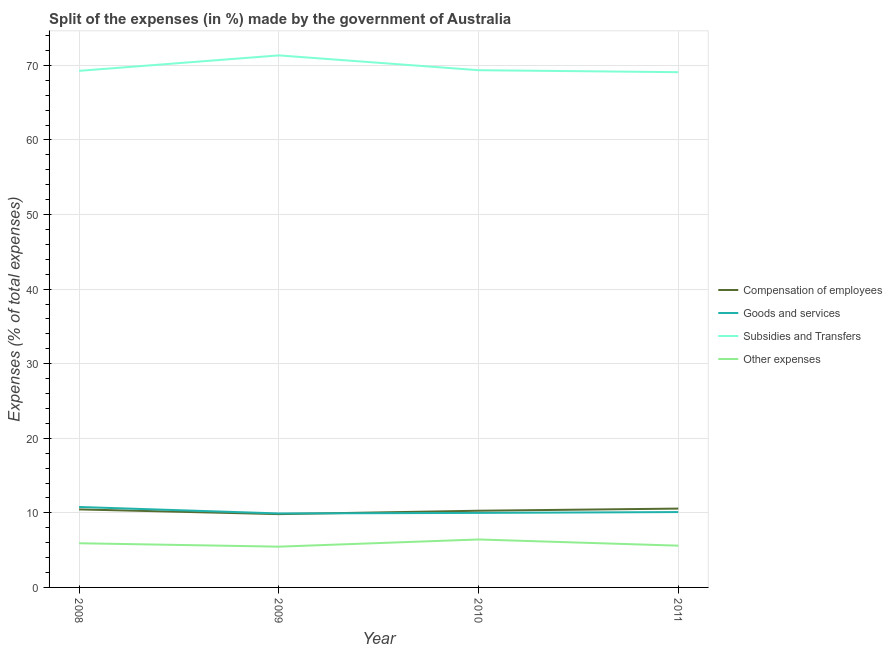How many different coloured lines are there?
Offer a very short reply. 4. Does the line corresponding to percentage of amount spent on other expenses intersect with the line corresponding to percentage of amount spent on goods and services?
Your answer should be compact. No. Is the number of lines equal to the number of legend labels?
Provide a short and direct response. Yes. What is the percentage of amount spent on compensation of employees in 2011?
Your answer should be compact. 10.57. Across all years, what is the maximum percentage of amount spent on other expenses?
Your answer should be very brief. 6.43. Across all years, what is the minimum percentage of amount spent on compensation of employees?
Your answer should be very brief. 9.83. In which year was the percentage of amount spent on other expenses minimum?
Provide a succinct answer. 2009. What is the total percentage of amount spent on compensation of employees in the graph?
Ensure brevity in your answer.  41.14. What is the difference between the percentage of amount spent on goods and services in 2008 and that in 2009?
Your answer should be compact. 0.87. What is the difference between the percentage of amount spent on other expenses in 2011 and the percentage of amount spent on goods and services in 2008?
Offer a terse response. -5.19. What is the average percentage of amount spent on subsidies per year?
Keep it short and to the point. 69.76. In the year 2011, what is the difference between the percentage of amount spent on subsidies and percentage of amount spent on goods and services?
Your answer should be very brief. 58.98. In how many years, is the percentage of amount spent on goods and services greater than 22 %?
Your answer should be very brief. 0. What is the ratio of the percentage of amount spent on compensation of employees in 2009 to that in 2011?
Your answer should be compact. 0.93. Is the difference between the percentage of amount spent on compensation of employees in 2008 and 2011 greater than the difference between the percentage of amount spent on goods and services in 2008 and 2011?
Your answer should be compact. No. What is the difference between the highest and the second highest percentage of amount spent on compensation of employees?
Provide a short and direct response. 0.11. What is the difference between the highest and the lowest percentage of amount spent on goods and services?
Give a very brief answer. 0.87. In how many years, is the percentage of amount spent on other expenses greater than the average percentage of amount spent on other expenses taken over all years?
Keep it short and to the point. 2. Is it the case that in every year, the sum of the percentage of amount spent on compensation of employees and percentage of amount spent on subsidies is greater than the sum of percentage of amount spent on goods and services and percentage of amount spent on other expenses?
Your answer should be very brief. Yes. Is it the case that in every year, the sum of the percentage of amount spent on compensation of employees and percentage of amount spent on goods and services is greater than the percentage of amount spent on subsidies?
Provide a short and direct response. No. Does the percentage of amount spent on compensation of employees monotonically increase over the years?
Ensure brevity in your answer.  No. Is the percentage of amount spent on compensation of employees strictly less than the percentage of amount spent on other expenses over the years?
Keep it short and to the point. No. What is the difference between two consecutive major ticks on the Y-axis?
Your answer should be compact. 10. Does the graph contain any zero values?
Provide a short and direct response. No. Does the graph contain grids?
Provide a short and direct response. Yes. How many legend labels are there?
Make the answer very short. 4. What is the title of the graph?
Your answer should be compact. Split of the expenses (in %) made by the government of Australia. Does "Sweden" appear as one of the legend labels in the graph?
Your response must be concise. No. What is the label or title of the Y-axis?
Offer a terse response. Expenses (% of total expenses). What is the Expenses (% of total expenses) of Compensation of employees in 2008?
Provide a short and direct response. 10.46. What is the Expenses (% of total expenses) in Goods and services in 2008?
Offer a very short reply. 10.79. What is the Expenses (% of total expenses) in Subsidies and Transfers in 2008?
Your response must be concise. 69.27. What is the Expenses (% of total expenses) in Other expenses in 2008?
Make the answer very short. 5.92. What is the Expenses (% of total expenses) of Compensation of employees in 2009?
Offer a terse response. 9.83. What is the Expenses (% of total expenses) of Goods and services in 2009?
Offer a terse response. 9.92. What is the Expenses (% of total expenses) in Subsidies and Transfers in 2009?
Ensure brevity in your answer.  71.34. What is the Expenses (% of total expenses) in Other expenses in 2009?
Your answer should be very brief. 5.47. What is the Expenses (% of total expenses) in Compensation of employees in 2010?
Your response must be concise. 10.28. What is the Expenses (% of total expenses) in Goods and services in 2010?
Offer a very short reply. 9.99. What is the Expenses (% of total expenses) in Subsidies and Transfers in 2010?
Offer a terse response. 69.35. What is the Expenses (% of total expenses) of Other expenses in 2010?
Provide a succinct answer. 6.43. What is the Expenses (% of total expenses) in Compensation of employees in 2011?
Offer a terse response. 10.57. What is the Expenses (% of total expenses) in Goods and services in 2011?
Your answer should be very brief. 10.11. What is the Expenses (% of total expenses) of Subsidies and Transfers in 2011?
Your response must be concise. 69.09. What is the Expenses (% of total expenses) of Other expenses in 2011?
Your answer should be compact. 5.6. Across all years, what is the maximum Expenses (% of total expenses) of Compensation of employees?
Offer a terse response. 10.57. Across all years, what is the maximum Expenses (% of total expenses) of Goods and services?
Give a very brief answer. 10.79. Across all years, what is the maximum Expenses (% of total expenses) of Subsidies and Transfers?
Offer a very short reply. 71.34. Across all years, what is the maximum Expenses (% of total expenses) of Other expenses?
Keep it short and to the point. 6.43. Across all years, what is the minimum Expenses (% of total expenses) of Compensation of employees?
Offer a terse response. 9.83. Across all years, what is the minimum Expenses (% of total expenses) of Goods and services?
Your answer should be compact. 9.92. Across all years, what is the minimum Expenses (% of total expenses) of Subsidies and Transfers?
Provide a succinct answer. 69.09. Across all years, what is the minimum Expenses (% of total expenses) in Other expenses?
Offer a terse response. 5.47. What is the total Expenses (% of total expenses) of Compensation of employees in the graph?
Offer a very short reply. 41.14. What is the total Expenses (% of total expenses) in Goods and services in the graph?
Your answer should be very brief. 40.8. What is the total Expenses (% of total expenses) of Subsidies and Transfers in the graph?
Ensure brevity in your answer.  279.05. What is the total Expenses (% of total expenses) in Other expenses in the graph?
Your answer should be compact. 23.42. What is the difference between the Expenses (% of total expenses) of Compensation of employees in 2008 and that in 2009?
Provide a succinct answer. 0.63. What is the difference between the Expenses (% of total expenses) of Goods and services in 2008 and that in 2009?
Offer a terse response. 0.87. What is the difference between the Expenses (% of total expenses) of Subsidies and Transfers in 2008 and that in 2009?
Offer a terse response. -2.07. What is the difference between the Expenses (% of total expenses) of Other expenses in 2008 and that in 2009?
Your answer should be very brief. 0.46. What is the difference between the Expenses (% of total expenses) in Compensation of employees in 2008 and that in 2010?
Ensure brevity in your answer.  0.18. What is the difference between the Expenses (% of total expenses) of Goods and services in 2008 and that in 2010?
Keep it short and to the point. 0.79. What is the difference between the Expenses (% of total expenses) of Subsidies and Transfers in 2008 and that in 2010?
Offer a terse response. -0.09. What is the difference between the Expenses (% of total expenses) of Other expenses in 2008 and that in 2010?
Offer a very short reply. -0.51. What is the difference between the Expenses (% of total expenses) of Compensation of employees in 2008 and that in 2011?
Provide a succinct answer. -0.11. What is the difference between the Expenses (% of total expenses) of Goods and services in 2008 and that in 2011?
Ensure brevity in your answer.  0.68. What is the difference between the Expenses (% of total expenses) in Subsidies and Transfers in 2008 and that in 2011?
Give a very brief answer. 0.18. What is the difference between the Expenses (% of total expenses) in Other expenses in 2008 and that in 2011?
Offer a terse response. 0.33. What is the difference between the Expenses (% of total expenses) in Compensation of employees in 2009 and that in 2010?
Your answer should be very brief. -0.45. What is the difference between the Expenses (% of total expenses) in Goods and services in 2009 and that in 2010?
Offer a terse response. -0.07. What is the difference between the Expenses (% of total expenses) in Subsidies and Transfers in 2009 and that in 2010?
Your answer should be very brief. 1.99. What is the difference between the Expenses (% of total expenses) in Other expenses in 2009 and that in 2010?
Ensure brevity in your answer.  -0.96. What is the difference between the Expenses (% of total expenses) of Compensation of employees in 2009 and that in 2011?
Your answer should be very brief. -0.74. What is the difference between the Expenses (% of total expenses) of Goods and services in 2009 and that in 2011?
Provide a short and direct response. -0.19. What is the difference between the Expenses (% of total expenses) of Subsidies and Transfers in 2009 and that in 2011?
Ensure brevity in your answer.  2.25. What is the difference between the Expenses (% of total expenses) of Other expenses in 2009 and that in 2011?
Ensure brevity in your answer.  -0.13. What is the difference between the Expenses (% of total expenses) of Compensation of employees in 2010 and that in 2011?
Provide a short and direct response. -0.29. What is the difference between the Expenses (% of total expenses) in Goods and services in 2010 and that in 2011?
Your response must be concise. -0.11. What is the difference between the Expenses (% of total expenses) of Subsidies and Transfers in 2010 and that in 2011?
Provide a succinct answer. 0.27. What is the difference between the Expenses (% of total expenses) of Other expenses in 2010 and that in 2011?
Give a very brief answer. 0.83. What is the difference between the Expenses (% of total expenses) of Compensation of employees in 2008 and the Expenses (% of total expenses) of Goods and services in 2009?
Your answer should be compact. 0.54. What is the difference between the Expenses (% of total expenses) of Compensation of employees in 2008 and the Expenses (% of total expenses) of Subsidies and Transfers in 2009?
Your answer should be very brief. -60.88. What is the difference between the Expenses (% of total expenses) in Compensation of employees in 2008 and the Expenses (% of total expenses) in Other expenses in 2009?
Provide a succinct answer. 4.99. What is the difference between the Expenses (% of total expenses) in Goods and services in 2008 and the Expenses (% of total expenses) in Subsidies and Transfers in 2009?
Ensure brevity in your answer.  -60.55. What is the difference between the Expenses (% of total expenses) in Goods and services in 2008 and the Expenses (% of total expenses) in Other expenses in 2009?
Offer a very short reply. 5.32. What is the difference between the Expenses (% of total expenses) of Subsidies and Transfers in 2008 and the Expenses (% of total expenses) of Other expenses in 2009?
Your response must be concise. 63.8. What is the difference between the Expenses (% of total expenses) in Compensation of employees in 2008 and the Expenses (% of total expenses) in Goods and services in 2010?
Provide a short and direct response. 0.47. What is the difference between the Expenses (% of total expenses) in Compensation of employees in 2008 and the Expenses (% of total expenses) in Subsidies and Transfers in 2010?
Your answer should be very brief. -58.89. What is the difference between the Expenses (% of total expenses) in Compensation of employees in 2008 and the Expenses (% of total expenses) in Other expenses in 2010?
Ensure brevity in your answer.  4.03. What is the difference between the Expenses (% of total expenses) in Goods and services in 2008 and the Expenses (% of total expenses) in Subsidies and Transfers in 2010?
Provide a short and direct response. -58.57. What is the difference between the Expenses (% of total expenses) in Goods and services in 2008 and the Expenses (% of total expenses) in Other expenses in 2010?
Keep it short and to the point. 4.36. What is the difference between the Expenses (% of total expenses) in Subsidies and Transfers in 2008 and the Expenses (% of total expenses) in Other expenses in 2010?
Give a very brief answer. 62.84. What is the difference between the Expenses (% of total expenses) in Compensation of employees in 2008 and the Expenses (% of total expenses) in Goods and services in 2011?
Provide a short and direct response. 0.36. What is the difference between the Expenses (% of total expenses) in Compensation of employees in 2008 and the Expenses (% of total expenses) in Subsidies and Transfers in 2011?
Give a very brief answer. -58.63. What is the difference between the Expenses (% of total expenses) in Compensation of employees in 2008 and the Expenses (% of total expenses) in Other expenses in 2011?
Ensure brevity in your answer.  4.86. What is the difference between the Expenses (% of total expenses) of Goods and services in 2008 and the Expenses (% of total expenses) of Subsidies and Transfers in 2011?
Keep it short and to the point. -58.3. What is the difference between the Expenses (% of total expenses) in Goods and services in 2008 and the Expenses (% of total expenses) in Other expenses in 2011?
Your answer should be compact. 5.19. What is the difference between the Expenses (% of total expenses) in Subsidies and Transfers in 2008 and the Expenses (% of total expenses) in Other expenses in 2011?
Your answer should be very brief. 63.67. What is the difference between the Expenses (% of total expenses) of Compensation of employees in 2009 and the Expenses (% of total expenses) of Goods and services in 2010?
Provide a succinct answer. -0.17. What is the difference between the Expenses (% of total expenses) in Compensation of employees in 2009 and the Expenses (% of total expenses) in Subsidies and Transfers in 2010?
Give a very brief answer. -59.53. What is the difference between the Expenses (% of total expenses) of Compensation of employees in 2009 and the Expenses (% of total expenses) of Other expenses in 2010?
Make the answer very short. 3.4. What is the difference between the Expenses (% of total expenses) in Goods and services in 2009 and the Expenses (% of total expenses) in Subsidies and Transfers in 2010?
Your response must be concise. -59.43. What is the difference between the Expenses (% of total expenses) of Goods and services in 2009 and the Expenses (% of total expenses) of Other expenses in 2010?
Provide a succinct answer. 3.49. What is the difference between the Expenses (% of total expenses) in Subsidies and Transfers in 2009 and the Expenses (% of total expenses) in Other expenses in 2010?
Ensure brevity in your answer.  64.91. What is the difference between the Expenses (% of total expenses) in Compensation of employees in 2009 and the Expenses (% of total expenses) in Goods and services in 2011?
Your answer should be very brief. -0.28. What is the difference between the Expenses (% of total expenses) in Compensation of employees in 2009 and the Expenses (% of total expenses) in Subsidies and Transfers in 2011?
Your answer should be very brief. -59.26. What is the difference between the Expenses (% of total expenses) of Compensation of employees in 2009 and the Expenses (% of total expenses) of Other expenses in 2011?
Your answer should be compact. 4.23. What is the difference between the Expenses (% of total expenses) of Goods and services in 2009 and the Expenses (% of total expenses) of Subsidies and Transfers in 2011?
Your response must be concise. -59.17. What is the difference between the Expenses (% of total expenses) of Goods and services in 2009 and the Expenses (% of total expenses) of Other expenses in 2011?
Ensure brevity in your answer.  4.32. What is the difference between the Expenses (% of total expenses) in Subsidies and Transfers in 2009 and the Expenses (% of total expenses) in Other expenses in 2011?
Provide a short and direct response. 65.74. What is the difference between the Expenses (% of total expenses) in Compensation of employees in 2010 and the Expenses (% of total expenses) in Goods and services in 2011?
Offer a terse response. 0.18. What is the difference between the Expenses (% of total expenses) of Compensation of employees in 2010 and the Expenses (% of total expenses) of Subsidies and Transfers in 2011?
Keep it short and to the point. -58.81. What is the difference between the Expenses (% of total expenses) of Compensation of employees in 2010 and the Expenses (% of total expenses) of Other expenses in 2011?
Offer a very short reply. 4.68. What is the difference between the Expenses (% of total expenses) of Goods and services in 2010 and the Expenses (% of total expenses) of Subsidies and Transfers in 2011?
Ensure brevity in your answer.  -59.1. What is the difference between the Expenses (% of total expenses) in Goods and services in 2010 and the Expenses (% of total expenses) in Other expenses in 2011?
Give a very brief answer. 4.39. What is the difference between the Expenses (% of total expenses) in Subsidies and Transfers in 2010 and the Expenses (% of total expenses) in Other expenses in 2011?
Keep it short and to the point. 63.76. What is the average Expenses (% of total expenses) of Compensation of employees per year?
Your answer should be very brief. 10.29. What is the average Expenses (% of total expenses) in Goods and services per year?
Provide a short and direct response. 10.2. What is the average Expenses (% of total expenses) in Subsidies and Transfers per year?
Make the answer very short. 69.76. What is the average Expenses (% of total expenses) of Other expenses per year?
Ensure brevity in your answer.  5.85. In the year 2008, what is the difference between the Expenses (% of total expenses) of Compensation of employees and Expenses (% of total expenses) of Goods and services?
Provide a succinct answer. -0.33. In the year 2008, what is the difference between the Expenses (% of total expenses) of Compensation of employees and Expenses (% of total expenses) of Subsidies and Transfers?
Provide a short and direct response. -58.81. In the year 2008, what is the difference between the Expenses (% of total expenses) in Compensation of employees and Expenses (% of total expenses) in Other expenses?
Give a very brief answer. 4.54. In the year 2008, what is the difference between the Expenses (% of total expenses) in Goods and services and Expenses (% of total expenses) in Subsidies and Transfers?
Offer a very short reply. -58.48. In the year 2008, what is the difference between the Expenses (% of total expenses) of Goods and services and Expenses (% of total expenses) of Other expenses?
Your response must be concise. 4.86. In the year 2008, what is the difference between the Expenses (% of total expenses) in Subsidies and Transfers and Expenses (% of total expenses) in Other expenses?
Offer a terse response. 63.34. In the year 2009, what is the difference between the Expenses (% of total expenses) in Compensation of employees and Expenses (% of total expenses) in Goods and services?
Give a very brief answer. -0.09. In the year 2009, what is the difference between the Expenses (% of total expenses) of Compensation of employees and Expenses (% of total expenses) of Subsidies and Transfers?
Make the answer very short. -61.51. In the year 2009, what is the difference between the Expenses (% of total expenses) in Compensation of employees and Expenses (% of total expenses) in Other expenses?
Give a very brief answer. 4.36. In the year 2009, what is the difference between the Expenses (% of total expenses) of Goods and services and Expenses (% of total expenses) of Subsidies and Transfers?
Offer a very short reply. -61.42. In the year 2009, what is the difference between the Expenses (% of total expenses) of Goods and services and Expenses (% of total expenses) of Other expenses?
Ensure brevity in your answer.  4.45. In the year 2009, what is the difference between the Expenses (% of total expenses) of Subsidies and Transfers and Expenses (% of total expenses) of Other expenses?
Keep it short and to the point. 65.87. In the year 2010, what is the difference between the Expenses (% of total expenses) of Compensation of employees and Expenses (% of total expenses) of Goods and services?
Your response must be concise. 0.29. In the year 2010, what is the difference between the Expenses (% of total expenses) of Compensation of employees and Expenses (% of total expenses) of Subsidies and Transfers?
Ensure brevity in your answer.  -59.07. In the year 2010, what is the difference between the Expenses (% of total expenses) in Compensation of employees and Expenses (% of total expenses) in Other expenses?
Your response must be concise. 3.85. In the year 2010, what is the difference between the Expenses (% of total expenses) in Goods and services and Expenses (% of total expenses) in Subsidies and Transfers?
Ensure brevity in your answer.  -59.36. In the year 2010, what is the difference between the Expenses (% of total expenses) of Goods and services and Expenses (% of total expenses) of Other expenses?
Give a very brief answer. 3.56. In the year 2010, what is the difference between the Expenses (% of total expenses) in Subsidies and Transfers and Expenses (% of total expenses) in Other expenses?
Offer a terse response. 62.92. In the year 2011, what is the difference between the Expenses (% of total expenses) in Compensation of employees and Expenses (% of total expenses) in Goods and services?
Keep it short and to the point. 0.46. In the year 2011, what is the difference between the Expenses (% of total expenses) of Compensation of employees and Expenses (% of total expenses) of Subsidies and Transfers?
Offer a terse response. -58.52. In the year 2011, what is the difference between the Expenses (% of total expenses) in Compensation of employees and Expenses (% of total expenses) in Other expenses?
Make the answer very short. 4.97. In the year 2011, what is the difference between the Expenses (% of total expenses) of Goods and services and Expenses (% of total expenses) of Subsidies and Transfers?
Your answer should be compact. -58.98. In the year 2011, what is the difference between the Expenses (% of total expenses) of Goods and services and Expenses (% of total expenses) of Other expenses?
Make the answer very short. 4.51. In the year 2011, what is the difference between the Expenses (% of total expenses) of Subsidies and Transfers and Expenses (% of total expenses) of Other expenses?
Make the answer very short. 63.49. What is the ratio of the Expenses (% of total expenses) of Compensation of employees in 2008 to that in 2009?
Offer a terse response. 1.06. What is the ratio of the Expenses (% of total expenses) in Goods and services in 2008 to that in 2009?
Give a very brief answer. 1.09. What is the ratio of the Expenses (% of total expenses) in Subsidies and Transfers in 2008 to that in 2009?
Your answer should be very brief. 0.97. What is the ratio of the Expenses (% of total expenses) of Other expenses in 2008 to that in 2009?
Provide a succinct answer. 1.08. What is the ratio of the Expenses (% of total expenses) of Compensation of employees in 2008 to that in 2010?
Your answer should be very brief. 1.02. What is the ratio of the Expenses (% of total expenses) in Goods and services in 2008 to that in 2010?
Your answer should be compact. 1.08. What is the ratio of the Expenses (% of total expenses) of Subsidies and Transfers in 2008 to that in 2010?
Provide a short and direct response. 1. What is the ratio of the Expenses (% of total expenses) in Other expenses in 2008 to that in 2010?
Provide a succinct answer. 0.92. What is the ratio of the Expenses (% of total expenses) in Goods and services in 2008 to that in 2011?
Offer a very short reply. 1.07. What is the ratio of the Expenses (% of total expenses) of Subsidies and Transfers in 2008 to that in 2011?
Provide a succinct answer. 1. What is the ratio of the Expenses (% of total expenses) in Other expenses in 2008 to that in 2011?
Offer a very short reply. 1.06. What is the ratio of the Expenses (% of total expenses) in Compensation of employees in 2009 to that in 2010?
Make the answer very short. 0.96. What is the ratio of the Expenses (% of total expenses) in Goods and services in 2009 to that in 2010?
Make the answer very short. 0.99. What is the ratio of the Expenses (% of total expenses) in Subsidies and Transfers in 2009 to that in 2010?
Your response must be concise. 1.03. What is the ratio of the Expenses (% of total expenses) of Other expenses in 2009 to that in 2010?
Offer a terse response. 0.85. What is the ratio of the Expenses (% of total expenses) in Compensation of employees in 2009 to that in 2011?
Make the answer very short. 0.93. What is the ratio of the Expenses (% of total expenses) in Goods and services in 2009 to that in 2011?
Provide a succinct answer. 0.98. What is the ratio of the Expenses (% of total expenses) of Subsidies and Transfers in 2009 to that in 2011?
Ensure brevity in your answer.  1.03. What is the ratio of the Expenses (% of total expenses) in Other expenses in 2009 to that in 2011?
Offer a terse response. 0.98. What is the ratio of the Expenses (% of total expenses) in Compensation of employees in 2010 to that in 2011?
Keep it short and to the point. 0.97. What is the ratio of the Expenses (% of total expenses) of Goods and services in 2010 to that in 2011?
Offer a terse response. 0.99. What is the ratio of the Expenses (% of total expenses) in Other expenses in 2010 to that in 2011?
Your response must be concise. 1.15. What is the difference between the highest and the second highest Expenses (% of total expenses) of Compensation of employees?
Make the answer very short. 0.11. What is the difference between the highest and the second highest Expenses (% of total expenses) of Goods and services?
Provide a short and direct response. 0.68. What is the difference between the highest and the second highest Expenses (% of total expenses) in Subsidies and Transfers?
Offer a terse response. 1.99. What is the difference between the highest and the second highest Expenses (% of total expenses) of Other expenses?
Provide a short and direct response. 0.51. What is the difference between the highest and the lowest Expenses (% of total expenses) of Compensation of employees?
Provide a succinct answer. 0.74. What is the difference between the highest and the lowest Expenses (% of total expenses) of Goods and services?
Offer a very short reply. 0.87. What is the difference between the highest and the lowest Expenses (% of total expenses) of Subsidies and Transfers?
Provide a succinct answer. 2.25. What is the difference between the highest and the lowest Expenses (% of total expenses) in Other expenses?
Give a very brief answer. 0.96. 